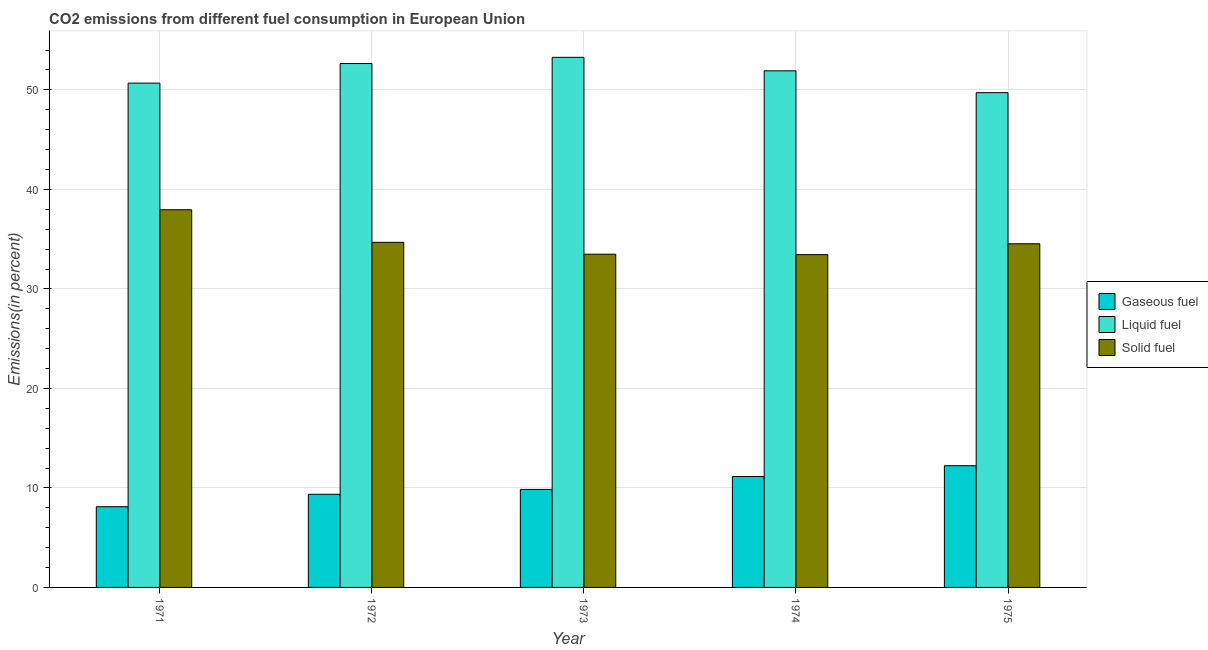How many groups of bars are there?
Give a very brief answer. 5. Are the number of bars on each tick of the X-axis equal?
Offer a very short reply. Yes. How many bars are there on the 2nd tick from the left?
Offer a terse response. 3. How many bars are there on the 2nd tick from the right?
Ensure brevity in your answer.  3. In how many cases, is the number of bars for a given year not equal to the number of legend labels?
Your answer should be compact. 0. What is the percentage of solid fuel emission in 1972?
Offer a terse response. 34.68. Across all years, what is the maximum percentage of gaseous fuel emission?
Keep it short and to the point. 12.23. Across all years, what is the minimum percentage of gaseous fuel emission?
Make the answer very short. 8.11. In which year was the percentage of liquid fuel emission maximum?
Provide a short and direct response. 1973. In which year was the percentage of solid fuel emission minimum?
Keep it short and to the point. 1974. What is the total percentage of solid fuel emission in the graph?
Provide a short and direct response. 174.1. What is the difference between the percentage of liquid fuel emission in 1972 and that in 1974?
Ensure brevity in your answer.  0.73. What is the difference between the percentage of liquid fuel emission in 1973 and the percentage of solid fuel emission in 1971?
Offer a very short reply. 2.59. What is the average percentage of gaseous fuel emission per year?
Ensure brevity in your answer.  10.14. In the year 1975, what is the difference between the percentage of gaseous fuel emission and percentage of liquid fuel emission?
Give a very brief answer. 0. What is the ratio of the percentage of solid fuel emission in 1971 to that in 1973?
Your response must be concise. 1.13. Is the percentage of liquid fuel emission in 1971 less than that in 1973?
Provide a succinct answer. Yes. What is the difference between the highest and the second highest percentage of liquid fuel emission?
Offer a terse response. 0.62. What is the difference between the highest and the lowest percentage of gaseous fuel emission?
Give a very brief answer. 4.12. In how many years, is the percentage of solid fuel emission greater than the average percentage of solid fuel emission taken over all years?
Provide a short and direct response. 1. Is the sum of the percentage of solid fuel emission in 1971 and 1973 greater than the maximum percentage of liquid fuel emission across all years?
Your answer should be very brief. Yes. What does the 3rd bar from the left in 1975 represents?
Give a very brief answer. Solid fuel. What does the 1st bar from the right in 1975 represents?
Provide a short and direct response. Solid fuel. Is it the case that in every year, the sum of the percentage of gaseous fuel emission and percentage of liquid fuel emission is greater than the percentage of solid fuel emission?
Your answer should be compact. Yes. How many bars are there?
Offer a very short reply. 15. How many years are there in the graph?
Make the answer very short. 5. Are the values on the major ticks of Y-axis written in scientific E-notation?
Offer a very short reply. No. Does the graph contain any zero values?
Make the answer very short. No. How many legend labels are there?
Ensure brevity in your answer.  3. How are the legend labels stacked?
Offer a very short reply. Vertical. What is the title of the graph?
Provide a succinct answer. CO2 emissions from different fuel consumption in European Union. What is the label or title of the X-axis?
Your answer should be very brief. Year. What is the label or title of the Y-axis?
Provide a succinct answer. Emissions(in percent). What is the Emissions(in percent) in Gaseous fuel in 1971?
Offer a very short reply. 8.11. What is the Emissions(in percent) of Liquid fuel in 1971?
Keep it short and to the point. 50.68. What is the Emissions(in percent) in Solid fuel in 1971?
Your answer should be compact. 37.96. What is the Emissions(in percent) in Gaseous fuel in 1972?
Provide a succinct answer. 9.36. What is the Emissions(in percent) of Liquid fuel in 1972?
Your response must be concise. 52.65. What is the Emissions(in percent) of Solid fuel in 1972?
Your answer should be compact. 34.68. What is the Emissions(in percent) of Gaseous fuel in 1973?
Offer a very short reply. 9.85. What is the Emissions(in percent) in Liquid fuel in 1973?
Your answer should be compact. 53.27. What is the Emissions(in percent) of Solid fuel in 1973?
Offer a terse response. 33.49. What is the Emissions(in percent) in Gaseous fuel in 1974?
Make the answer very short. 11.15. What is the Emissions(in percent) of Liquid fuel in 1974?
Offer a terse response. 51.92. What is the Emissions(in percent) in Solid fuel in 1974?
Give a very brief answer. 33.44. What is the Emissions(in percent) of Gaseous fuel in 1975?
Offer a very short reply. 12.23. What is the Emissions(in percent) in Liquid fuel in 1975?
Ensure brevity in your answer.  49.72. What is the Emissions(in percent) of Solid fuel in 1975?
Your response must be concise. 34.54. Across all years, what is the maximum Emissions(in percent) in Gaseous fuel?
Provide a short and direct response. 12.23. Across all years, what is the maximum Emissions(in percent) of Liquid fuel?
Your answer should be compact. 53.27. Across all years, what is the maximum Emissions(in percent) in Solid fuel?
Make the answer very short. 37.96. Across all years, what is the minimum Emissions(in percent) in Gaseous fuel?
Your answer should be compact. 8.11. Across all years, what is the minimum Emissions(in percent) in Liquid fuel?
Give a very brief answer. 49.72. Across all years, what is the minimum Emissions(in percent) in Solid fuel?
Make the answer very short. 33.44. What is the total Emissions(in percent) of Gaseous fuel in the graph?
Keep it short and to the point. 50.7. What is the total Emissions(in percent) in Liquid fuel in the graph?
Provide a succinct answer. 258.24. What is the total Emissions(in percent) of Solid fuel in the graph?
Your response must be concise. 174.1. What is the difference between the Emissions(in percent) of Gaseous fuel in 1971 and that in 1972?
Your answer should be compact. -1.25. What is the difference between the Emissions(in percent) in Liquid fuel in 1971 and that in 1972?
Your response must be concise. -1.97. What is the difference between the Emissions(in percent) in Solid fuel in 1971 and that in 1972?
Give a very brief answer. 3.28. What is the difference between the Emissions(in percent) in Gaseous fuel in 1971 and that in 1973?
Offer a very short reply. -1.74. What is the difference between the Emissions(in percent) of Liquid fuel in 1971 and that in 1973?
Make the answer very short. -2.59. What is the difference between the Emissions(in percent) in Solid fuel in 1971 and that in 1973?
Give a very brief answer. 4.47. What is the difference between the Emissions(in percent) in Gaseous fuel in 1971 and that in 1974?
Your answer should be compact. -3.04. What is the difference between the Emissions(in percent) of Liquid fuel in 1971 and that in 1974?
Provide a succinct answer. -1.24. What is the difference between the Emissions(in percent) of Solid fuel in 1971 and that in 1974?
Offer a terse response. 4.51. What is the difference between the Emissions(in percent) of Gaseous fuel in 1971 and that in 1975?
Offer a very short reply. -4.12. What is the difference between the Emissions(in percent) of Liquid fuel in 1971 and that in 1975?
Your response must be concise. 0.96. What is the difference between the Emissions(in percent) in Solid fuel in 1971 and that in 1975?
Keep it short and to the point. 3.42. What is the difference between the Emissions(in percent) of Gaseous fuel in 1972 and that in 1973?
Give a very brief answer. -0.49. What is the difference between the Emissions(in percent) in Liquid fuel in 1972 and that in 1973?
Your response must be concise. -0.62. What is the difference between the Emissions(in percent) in Solid fuel in 1972 and that in 1973?
Your answer should be compact. 1.19. What is the difference between the Emissions(in percent) of Gaseous fuel in 1972 and that in 1974?
Give a very brief answer. -1.79. What is the difference between the Emissions(in percent) of Liquid fuel in 1972 and that in 1974?
Your answer should be compact. 0.73. What is the difference between the Emissions(in percent) in Solid fuel in 1972 and that in 1974?
Your response must be concise. 1.24. What is the difference between the Emissions(in percent) in Gaseous fuel in 1972 and that in 1975?
Ensure brevity in your answer.  -2.87. What is the difference between the Emissions(in percent) in Liquid fuel in 1972 and that in 1975?
Give a very brief answer. 2.93. What is the difference between the Emissions(in percent) in Solid fuel in 1972 and that in 1975?
Keep it short and to the point. 0.14. What is the difference between the Emissions(in percent) of Gaseous fuel in 1973 and that in 1974?
Offer a terse response. -1.3. What is the difference between the Emissions(in percent) of Liquid fuel in 1973 and that in 1974?
Your answer should be very brief. 1.35. What is the difference between the Emissions(in percent) in Solid fuel in 1973 and that in 1974?
Your answer should be compact. 0.04. What is the difference between the Emissions(in percent) of Gaseous fuel in 1973 and that in 1975?
Ensure brevity in your answer.  -2.38. What is the difference between the Emissions(in percent) in Liquid fuel in 1973 and that in 1975?
Keep it short and to the point. 3.55. What is the difference between the Emissions(in percent) of Solid fuel in 1973 and that in 1975?
Provide a succinct answer. -1.05. What is the difference between the Emissions(in percent) in Gaseous fuel in 1974 and that in 1975?
Give a very brief answer. -1.08. What is the difference between the Emissions(in percent) of Liquid fuel in 1974 and that in 1975?
Offer a very short reply. 2.2. What is the difference between the Emissions(in percent) in Solid fuel in 1974 and that in 1975?
Provide a short and direct response. -1.09. What is the difference between the Emissions(in percent) in Gaseous fuel in 1971 and the Emissions(in percent) in Liquid fuel in 1972?
Provide a succinct answer. -44.54. What is the difference between the Emissions(in percent) of Gaseous fuel in 1971 and the Emissions(in percent) of Solid fuel in 1972?
Offer a terse response. -26.57. What is the difference between the Emissions(in percent) of Liquid fuel in 1971 and the Emissions(in percent) of Solid fuel in 1972?
Give a very brief answer. 16. What is the difference between the Emissions(in percent) in Gaseous fuel in 1971 and the Emissions(in percent) in Liquid fuel in 1973?
Ensure brevity in your answer.  -45.16. What is the difference between the Emissions(in percent) of Gaseous fuel in 1971 and the Emissions(in percent) of Solid fuel in 1973?
Offer a very short reply. -25.38. What is the difference between the Emissions(in percent) in Liquid fuel in 1971 and the Emissions(in percent) in Solid fuel in 1973?
Provide a succinct answer. 17.19. What is the difference between the Emissions(in percent) of Gaseous fuel in 1971 and the Emissions(in percent) of Liquid fuel in 1974?
Ensure brevity in your answer.  -43.81. What is the difference between the Emissions(in percent) in Gaseous fuel in 1971 and the Emissions(in percent) in Solid fuel in 1974?
Your response must be concise. -25.33. What is the difference between the Emissions(in percent) in Liquid fuel in 1971 and the Emissions(in percent) in Solid fuel in 1974?
Your answer should be very brief. 17.23. What is the difference between the Emissions(in percent) in Gaseous fuel in 1971 and the Emissions(in percent) in Liquid fuel in 1975?
Offer a terse response. -41.61. What is the difference between the Emissions(in percent) in Gaseous fuel in 1971 and the Emissions(in percent) in Solid fuel in 1975?
Your answer should be very brief. -26.43. What is the difference between the Emissions(in percent) of Liquid fuel in 1971 and the Emissions(in percent) of Solid fuel in 1975?
Offer a very short reply. 16.14. What is the difference between the Emissions(in percent) in Gaseous fuel in 1972 and the Emissions(in percent) in Liquid fuel in 1973?
Ensure brevity in your answer.  -43.91. What is the difference between the Emissions(in percent) in Gaseous fuel in 1972 and the Emissions(in percent) in Solid fuel in 1973?
Provide a succinct answer. -24.13. What is the difference between the Emissions(in percent) in Liquid fuel in 1972 and the Emissions(in percent) in Solid fuel in 1973?
Provide a short and direct response. 19.16. What is the difference between the Emissions(in percent) of Gaseous fuel in 1972 and the Emissions(in percent) of Liquid fuel in 1974?
Your response must be concise. -42.56. What is the difference between the Emissions(in percent) in Gaseous fuel in 1972 and the Emissions(in percent) in Solid fuel in 1974?
Offer a very short reply. -24.08. What is the difference between the Emissions(in percent) in Liquid fuel in 1972 and the Emissions(in percent) in Solid fuel in 1974?
Ensure brevity in your answer.  19.2. What is the difference between the Emissions(in percent) in Gaseous fuel in 1972 and the Emissions(in percent) in Liquid fuel in 1975?
Offer a terse response. -40.36. What is the difference between the Emissions(in percent) in Gaseous fuel in 1972 and the Emissions(in percent) in Solid fuel in 1975?
Offer a very short reply. -25.18. What is the difference between the Emissions(in percent) in Liquid fuel in 1972 and the Emissions(in percent) in Solid fuel in 1975?
Ensure brevity in your answer.  18.11. What is the difference between the Emissions(in percent) in Gaseous fuel in 1973 and the Emissions(in percent) in Liquid fuel in 1974?
Ensure brevity in your answer.  -42.07. What is the difference between the Emissions(in percent) in Gaseous fuel in 1973 and the Emissions(in percent) in Solid fuel in 1974?
Provide a succinct answer. -23.6. What is the difference between the Emissions(in percent) of Liquid fuel in 1973 and the Emissions(in percent) of Solid fuel in 1974?
Your response must be concise. 19.83. What is the difference between the Emissions(in percent) of Gaseous fuel in 1973 and the Emissions(in percent) of Liquid fuel in 1975?
Make the answer very short. -39.87. What is the difference between the Emissions(in percent) of Gaseous fuel in 1973 and the Emissions(in percent) of Solid fuel in 1975?
Provide a short and direct response. -24.69. What is the difference between the Emissions(in percent) of Liquid fuel in 1973 and the Emissions(in percent) of Solid fuel in 1975?
Provide a succinct answer. 18.74. What is the difference between the Emissions(in percent) in Gaseous fuel in 1974 and the Emissions(in percent) in Liquid fuel in 1975?
Provide a succinct answer. -38.57. What is the difference between the Emissions(in percent) in Gaseous fuel in 1974 and the Emissions(in percent) in Solid fuel in 1975?
Offer a terse response. -23.39. What is the difference between the Emissions(in percent) of Liquid fuel in 1974 and the Emissions(in percent) of Solid fuel in 1975?
Your response must be concise. 17.38. What is the average Emissions(in percent) of Gaseous fuel per year?
Ensure brevity in your answer.  10.14. What is the average Emissions(in percent) in Liquid fuel per year?
Your answer should be very brief. 51.65. What is the average Emissions(in percent) of Solid fuel per year?
Provide a succinct answer. 34.82. In the year 1971, what is the difference between the Emissions(in percent) of Gaseous fuel and Emissions(in percent) of Liquid fuel?
Make the answer very short. -42.57. In the year 1971, what is the difference between the Emissions(in percent) of Gaseous fuel and Emissions(in percent) of Solid fuel?
Offer a very short reply. -29.84. In the year 1971, what is the difference between the Emissions(in percent) of Liquid fuel and Emissions(in percent) of Solid fuel?
Ensure brevity in your answer.  12.72. In the year 1972, what is the difference between the Emissions(in percent) in Gaseous fuel and Emissions(in percent) in Liquid fuel?
Your answer should be very brief. -43.29. In the year 1972, what is the difference between the Emissions(in percent) in Gaseous fuel and Emissions(in percent) in Solid fuel?
Provide a short and direct response. -25.32. In the year 1972, what is the difference between the Emissions(in percent) in Liquid fuel and Emissions(in percent) in Solid fuel?
Keep it short and to the point. 17.97. In the year 1973, what is the difference between the Emissions(in percent) of Gaseous fuel and Emissions(in percent) of Liquid fuel?
Your answer should be compact. -43.42. In the year 1973, what is the difference between the Emissions(in percent) in Gaseous fuel and Emissions(in percent) in Solid fuel?
Provide a succinct answer. -23.64. In the year 1973, what is the difference between the Emissions(in percent) in Liquid fuel and Emissions(in percent) in Solid fuel?
Offer a terse response. 19.78. In the year 1974, what is the difference between the Emissions(in percent) in Gaseous fuel and Emissions(in percent) in Liquid fuel?
Your response must be concise. -40.77. In the year 1974, what is the difference between the Emissions(in percent) of Gaseous fuel and Emissions(in percent) of Solid fuel?
Ensure brevity in your answer.  -22.3. In the year 1974, what is the difference between the Emissions(in percent) in Liquid fuel and Emissions(in percent) in Solid fuel?
Your answer should be very brief. 18.47. In the year 1975, what is the difference between the Emissions(in percent) of Gaseous fuel and Emissions(in percent) of Liquid fuel?
Give a very brief answer. -37.49. In the year 1975, what is the difference between the Emissions(in percent) of Gaseous fuel and Emissions(in percent) of Solid fuel?
Ensure brevity in your answer.  -22.3. In the year 1975, what is the difference between the Emissions(in percent) in Liquid fuel and Emissions(in percent) in Solid fuel?
Your response must be concise. 15.18. What is the ratio of the Emissions(in percent) of Gaseous fuel in 1971 to that in 1972?
Provide a succinct answer. 0.87. What is the ratio of the Emissions(in percent) of Liquid fuel in 1971 to that in 1972?
Offer a very short reply. 0.96. What is the ratio of the Emissions(in percent) in Solid fuel in 1971 to that in 1972?
Your response must be concise. 1.09. What is the ratio of the Emissions(in percent) in Gaseous fuel in 1971 to that in 1973?
Make the answer very short. 0.82. What is the ratio of the Emissions(in percent) in Liquid fuel in 1971 to that in 1973?
Your answer should be compact. 0.95. What is the ratio of the Emissions(in percent) in Solid fuel in 1971 to that in 1973?
Keep it short and to the point. 1.13. What is the ratio of the Emissions(in percent) in Gaseous fuel in 1971 to that in 1974?
Your response must be concise. 0.73. What is the ratio of the Emissions(in percent) of Liquid fuel in 1971 to that in 1974?
Provide a succinct answer. 0.98. What is the ratio of the Emissions(in percent) of Solid fuel in 1971 to that in 1974?
Offer a very short reply. 1.13. What is the ratio of the Emissions(in percent) in Gaseous fuel in 1971 to that in 1975?
Keep it short and to the point. 0.66. What is the ratio of the Emissions(in percent) of Liquid fuel in 1971 to that in 1975?
Your answer should be compact. 1.02. What is the ratio of the Emissions(in percent) of Solid fuel in 1971 to that in 1975?
Give a very brief answer. 1.1. What is the ratio of the Emissions(in percent) in Gaseous fuel in 1972 to that in 1973?
Keep it short and to the point. 0.95. What is the ratio of the Emissions(in percent) of Liquid fuel in 1972 to that in 1973?
Provide a succinct answer. 0.99. What is the ratio of the Emissions(in percent) of Solid fuel in 1972 to that in 1973?
Ensure brevity in your answer.  1.04. What is the ratio of the Emissions(in percent) of Gaseous fuel in 1972 to that in 1974?
Your answer should be compact. 0.84. What is the ratio of the Emissions(in percent) in Liquid fuel in 1972 to that in 1974?
Ensure brevity in your answer.  1.01. What is the ratio of the Emissions(in percent) of Solid fuel in 1972 to that in 1974?
Your answer should be very brief. 1.04. What is the ratio of the Emissions(in percent) of Gaseous fuel in 1972 to that in 1975?
Your answer should be very brief. 0.77. What is the ratio of the Emissions(in percent) in Liquid fuel in 1972 to that in 1975?
Make the answer very short. 1.06. What is the ratio of the Emissions(in percent) in Gaseous fuel in 1973 to that in 1974?
Ensure brevity in your answer.  0.88. What is the ratio of the Emissions(in percent) in Liquid fuel in 1973 to that in 1974?
Offer a terse response. 1.03. What is the ratio of the Emissions(in percent) of Gaseous fuel in 1973 to that in 1975?
Provide a short and direct response. 0.81. What is the ratio of the Emissions(in percent) in Liquid fuel in 1973 to that in 1975?
Make the answer very short. 1.07. What is the ratio of the Emissions(in percent) of Solid fuel in 1973 to that in 1975?
Your answer should be compact. 0.97. What is the ratio of the Emissions(in percent) of Gaseous fuel in 1974 to that in 1975?
Your answer should be very brief. 0.91. What is the ratio of the Emissions(in percent) of Liquid fuel in 1974 to that in 1975?
Offer a terse response. 1.04. What is the ratio of the Emissions(in percent) of Solid fuel in 1974 to that in 1975?
Offer a terse response. 0.97. What is the difference between the highest and the second highest Emissions(in percent) in Gaseous fuel?
Your answer should be compact. 1.08. What is the difference between the highest and the second highest Emissions(in percent) of Liquid fuel?
Your answer should be compact. 0.62. What is the difference between the highest and the second highest Emissions(in percent) in Solid fuel?
Provide a short and direct response. 3.28. What is the difference between the highest and the lowest Emissions(in percent) in Gaseous fuel?
Your answer should be compact. 4.12. What is the difference between the highest and the lowest Emissions(in percent) of Liquid fuel?
Keep it short and to the point. 3.55. What is the difference between the highest and the lowest Emissions(in percent) in Solid fuel?
Keep it short and to the point. 4.51. 